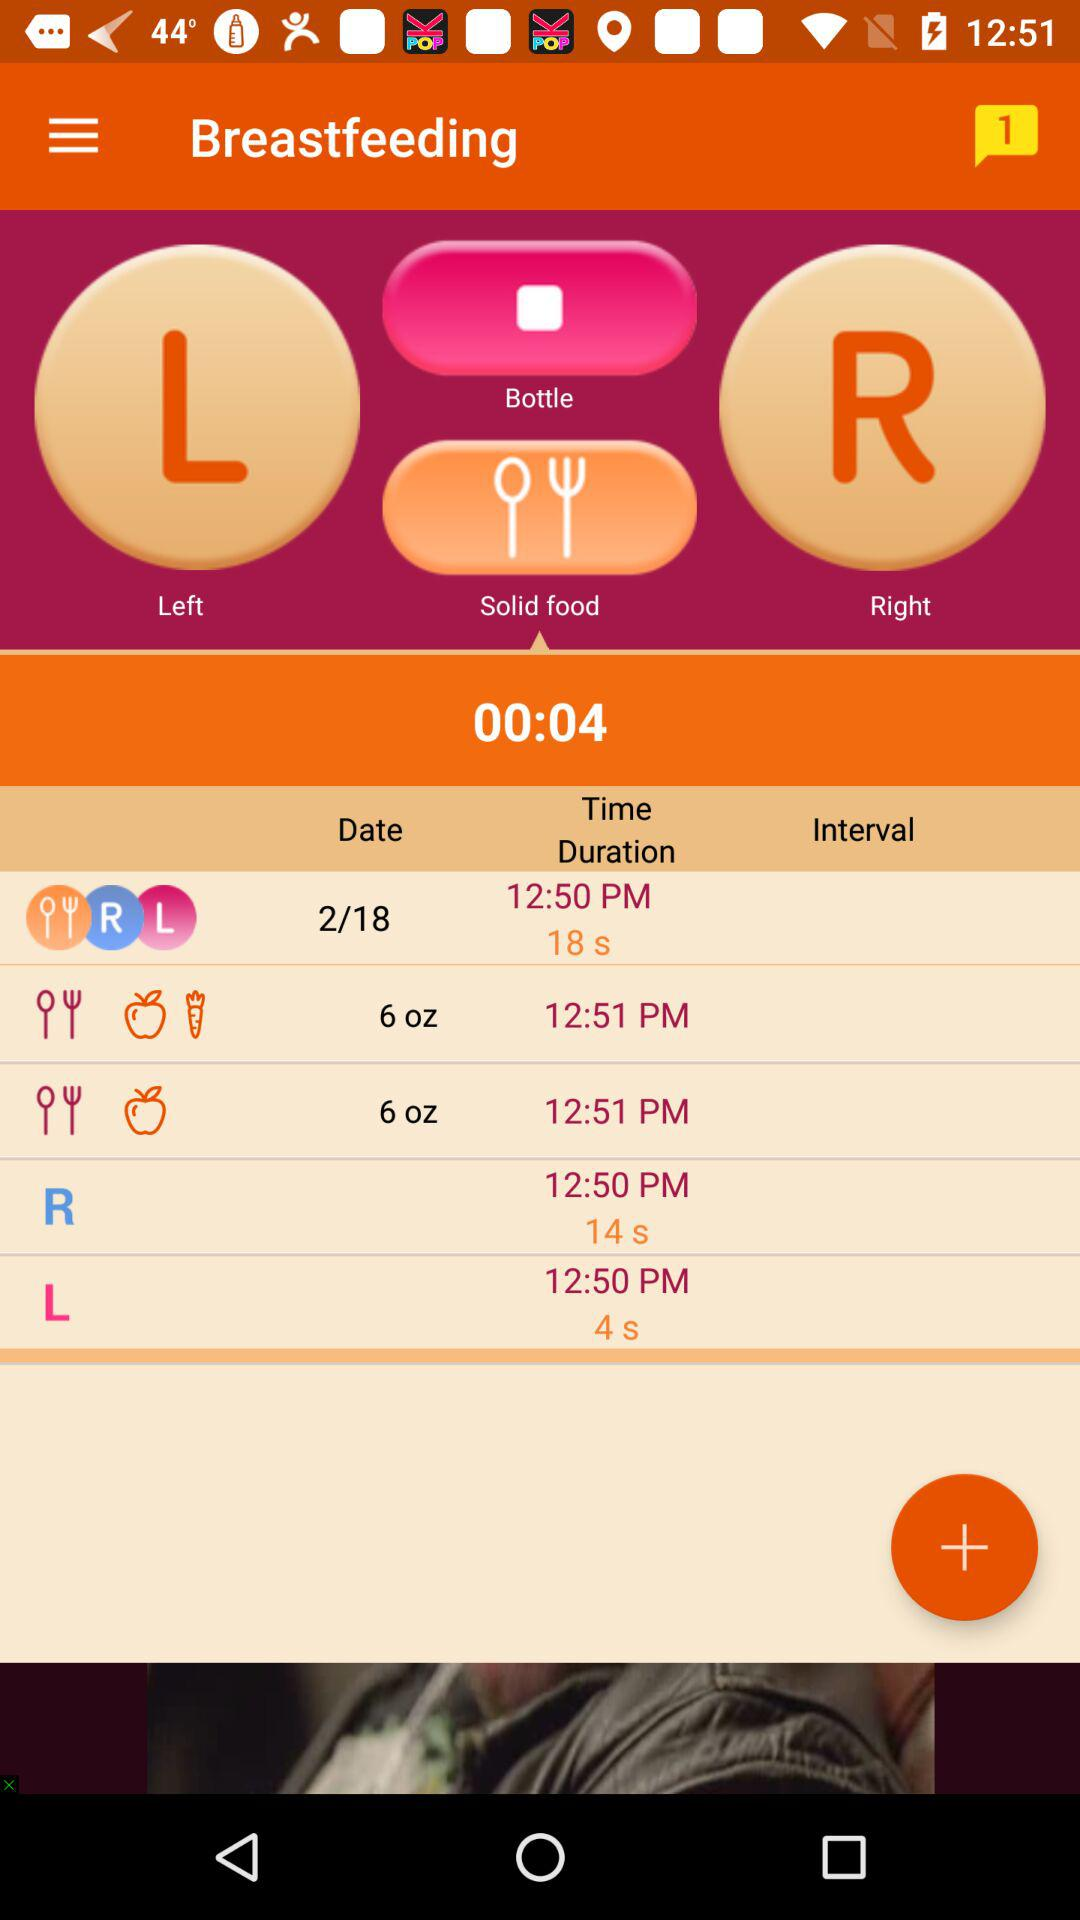How much time was taken on 2/18 for breastfeeding? The time taken on 2/18 for breastfeeding was 18 seconds. 